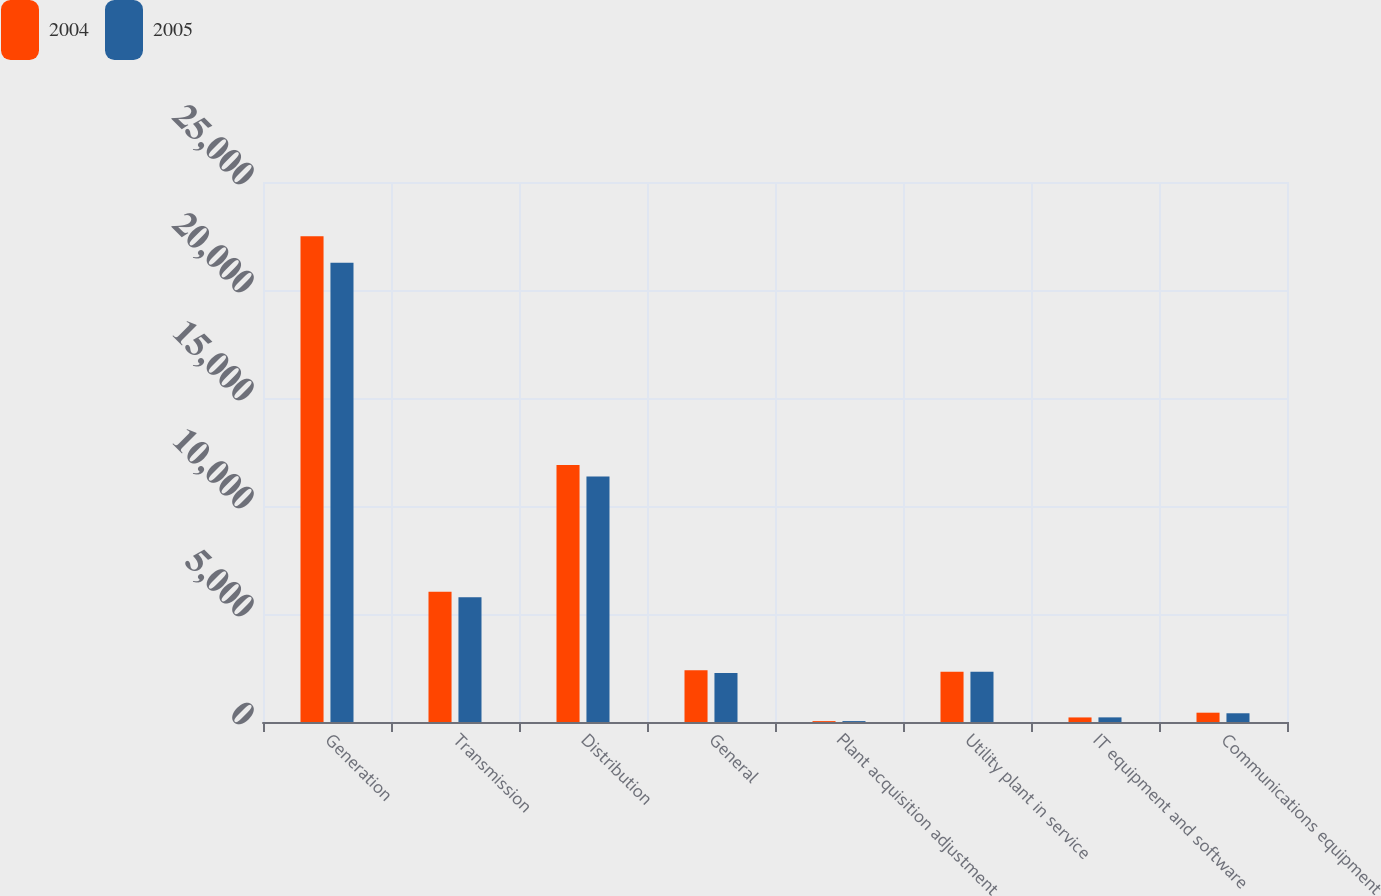Convert chart. <chart><loc_0><loc_0><loc_500><loc_500><stacked_bar_chart><ecel><fcel>Generation<fcel>Transmission<fcel>Distribution<fcel>General<fcel>Plant acquisition adjustment<fcel>Utility plant in service<fcel>IT equipment and software<fcel>Communications equipment<nl><fcel>2004<fcel>22490<fcel>6031<fcel>11894<fcel>2393<fcel>41<fcel>2330.5<fcel>211<fcel>431<nl><fcel>2005<fcel>21262<fcel>5770<fcel>11368<fcel>2268<fcel>42<fcel>2330.5<fcel>214<fcel>404<nl></chart> 